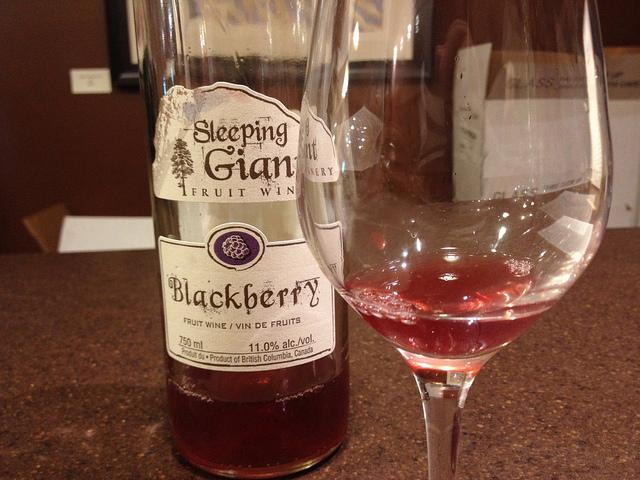What is the percent of alcohol? eleven 